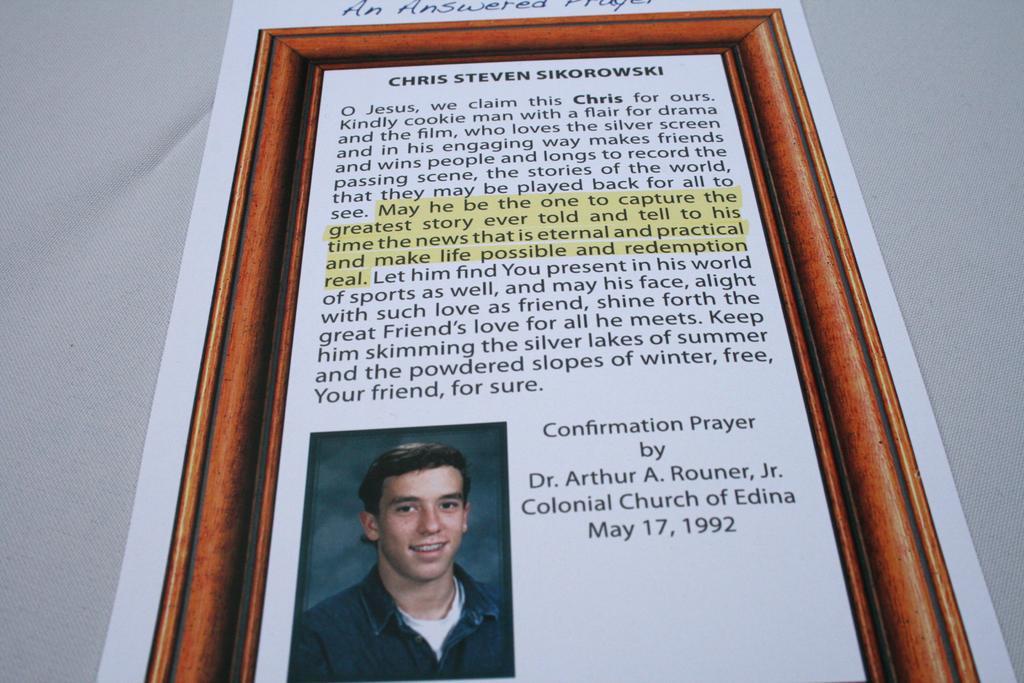In one or two sentences, can you explain what this image depicts? In this image there is a frame in which there is a photo of a man at the bottom. At the top there is some text. 